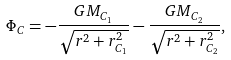<formula> <loc_0><loc_0><loc_500><loc_500>\Phi _ { C } = - \frac { G M _ { C _ { 1 } } } { \sqrt { r ^ { 2 } + r ^ { 2 } _ { C _ { 1 } } } } - \frac { G M _ { C _ { 2 } } } { \sqrt { r ^ { 2 } + r ^ { 2 } _ { C _ { 2 } } } } , \\</formula> 